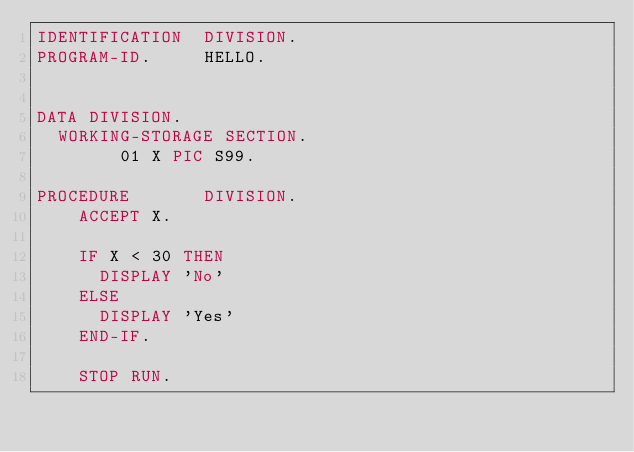<code> <loc_0><loc_0><loc_500><loc_500><_COBOL_>IDENTIFICATION  DIVISION.
PROGRAM-ID.     HELLO.

 
DATA DIVISION.
	WORKING-STORAGE SECTION.
        01 X PIC S99.
      
PROCEDURE       DIVISION.
    ACCEPT X.
    
    IF X < 30 THEN 
      DISPLAY 'No'
    ELSE
      DISPLAY 'Yes'
    END-IF.
    
    STOP RUN.</code> 